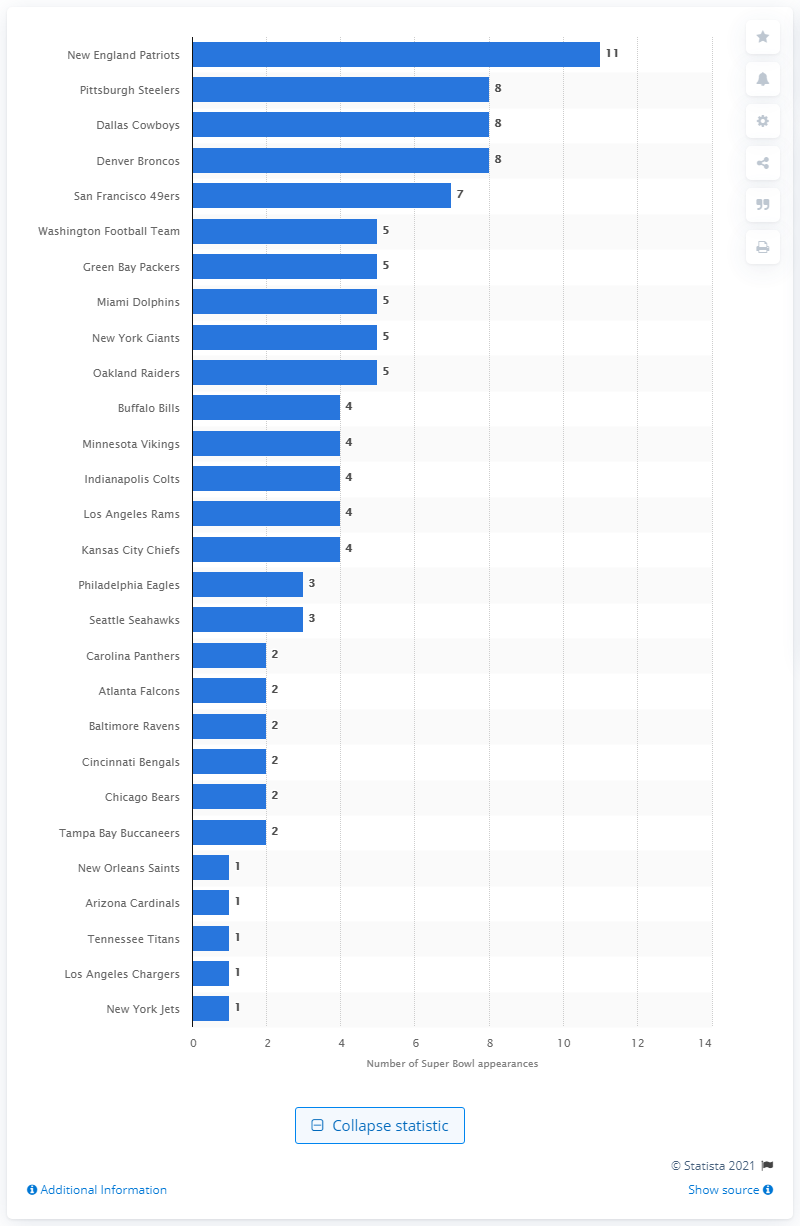Highlight a few significant elements in this photo. The New England Patriots have appeared in the Super Bowl more times than any other team, making them the most frequent participants in this prestigious NFL championship game. 